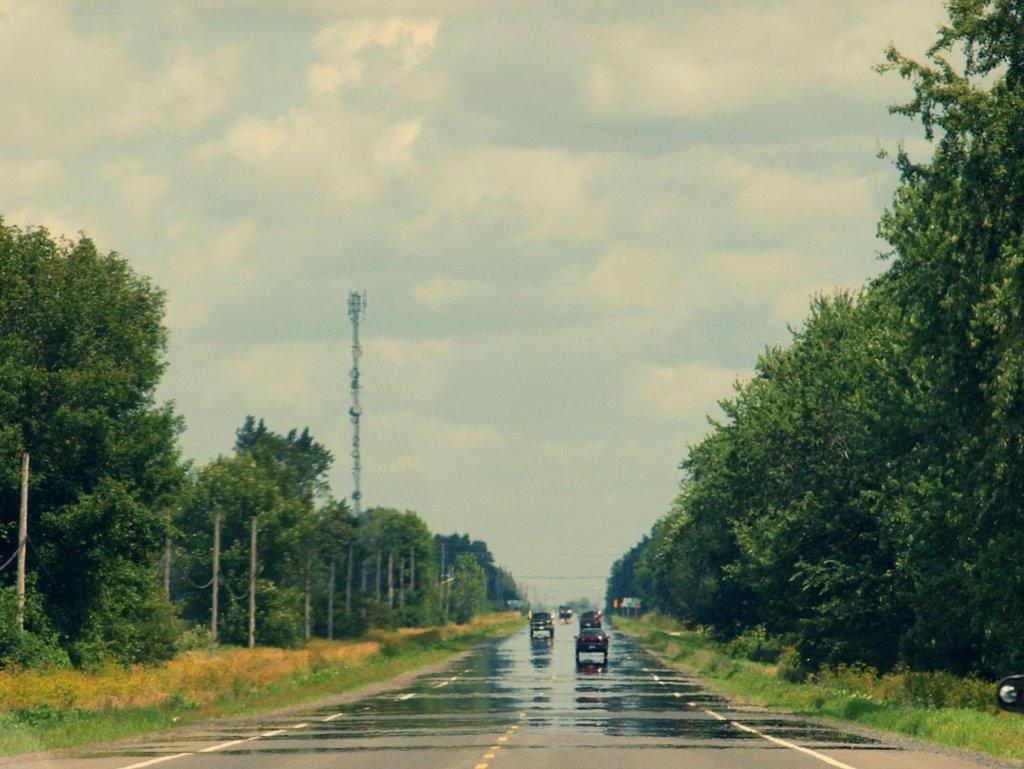What can be seen on the road in the image? There are vehicles on the road in the image. What type of vegetation is present in the image? There is grass, plants, and trees in the image. What structures can be seen in the image? There are poles and a board in the image. What is visible in the background of the image? The sky is visible in the background of the image, and there are clouds in the sky. What type of zinc is used to make the vehicles in the image? There is no information about the type of zinc used in the vehicles in the image. How much payment is required to use the board in the image? There is no indication of payment required for using the board in the image. 